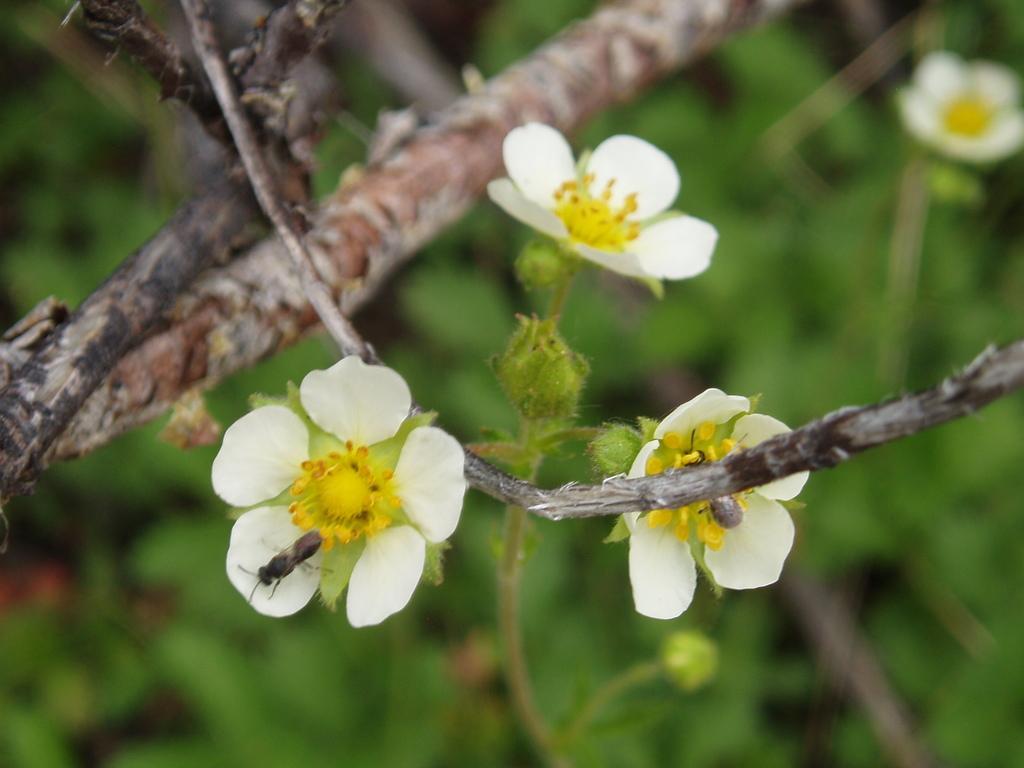Describe this image in one or two sentences. There are two bees, on the flowers of a tree. In the background, there are flowers and trees. 